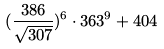<formula> <loc_0><loc_0><loc_500><loc_500>( \frac { 3 8 6 } { \sqrt { 3 0 7 } } ) ^ { 6 } \cdot 3 6 3 ^ { 9 } + 4 0 4</formula> 